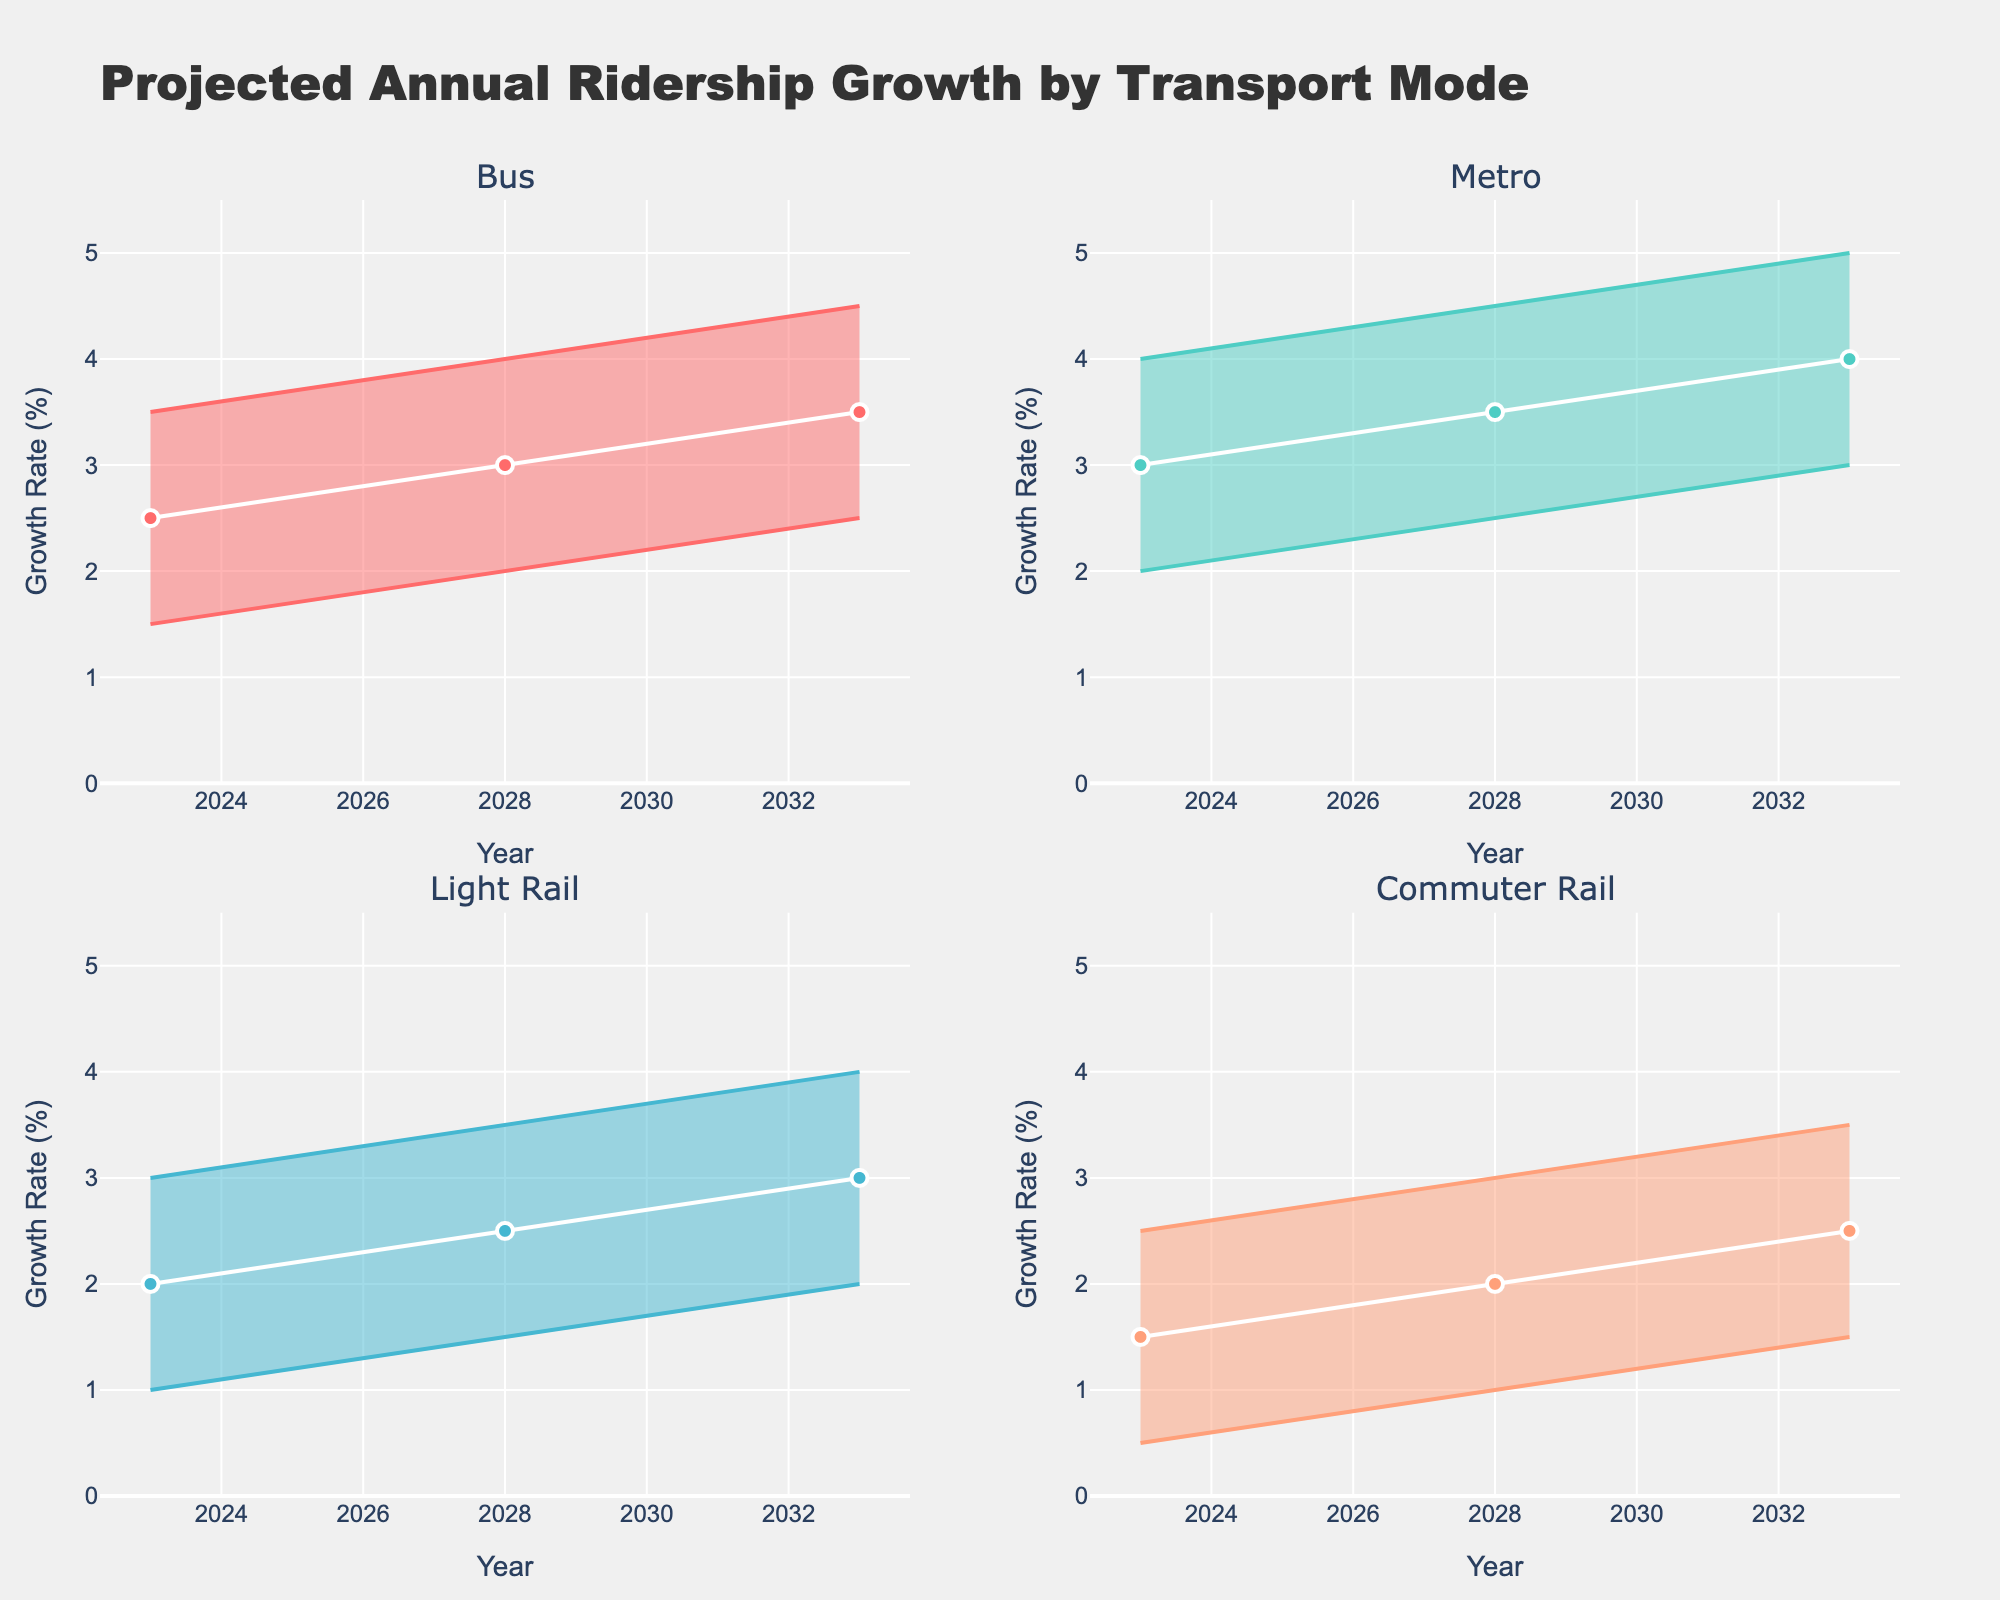What is the title of the figure? The title is usually at the top of the figure. Looking at the top, the title is "Projected Annual Ridership Growth by Transport Mode."
Answer: Projected Annual Ridership Growth by Transport Mode What are the transport modes compared in the figure? Transport modes are given as subplot titles. By examining all subplots, the modes compared are Bus, Metro, Light Rail, and Commuter Rail.
Answer: Bus, Metro, Light Rail, Commuter Rail Which transport mode has the highest median growth rate in 2033? Look at the median lines (white) for 2033 in each subplot. The highest median value among all is in the Metro subplot with a median of 4.0.
Answer: Metro What is the range of projected growth rates for Commuter Rail in 2028? Find Commuter Rail subplot for 2028. Look at the Lower and Upper values. The range is from 1.0 (Lower) to 3.0 (Upper).
Answer: 1.0 to 3.0 How does the median growth rate for Light Rail change from 2023 to 2033? Examine the median values (white lines) in the Light Rail subplot for 2023 and 2033. In 2023, the median is 2.0. In 2033, it is 3.0. The change is 3.0 - 2.0.
Answer: Increase by 1.0 Which mode shows the smallest range in growth rates in 2023? Compare the range (Upper - Lower) in 2023 for all modes. Bus: 3.5-1.5=2.0, Metro: 4.0-2.0=2.0, Light Rail: 3.0-1.0=2.0, Commuter Rail: 2.5-0.5=2.0. All modes have the same range.
Answer: All have the same What is the interquartile range (IQR) for Metro in 2028? IQR is Q3 - Q1. For Metro in 2028, Q3 is 4.0 and Q1 is 3.0, so IQR = 4.0 - 3.0.
Answer: 1.0 Which transport mode has the steepest projected increase in the median growth rate over the decade? Compare the change in medians from 2023 to 2033 for all modes. Metro: 4.0-3.0=1.0, Bus: 3.5-2.5=1.0, Light Rail: 3.0-2.0=1.0, Commuter Rail: 2.5-1.5=1.0. Bus, Metro, and Light Rail have the steepest increase.
Answer: Bus, Metro, Light Rail What color represents the Bus data in the figure? Find the subplot for Bus and identify the color used for Upper and Lower bounds. The color used is '#FF6B6B'.
Answer: Red 